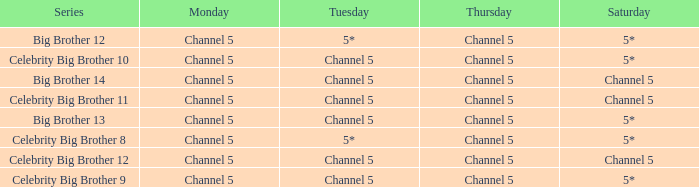Which Tuesday does big brother 12 air? 5*. 